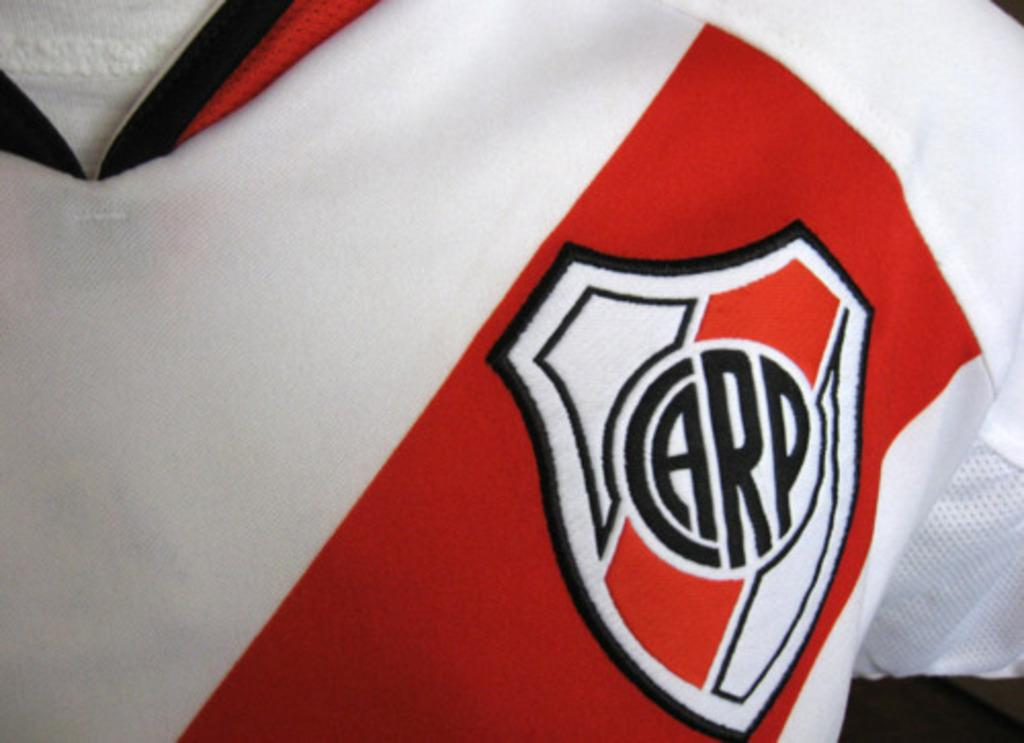<image>
Offer a succinct explanation of the picture presented. A jersey with a patch that says Carp sewn into it. 